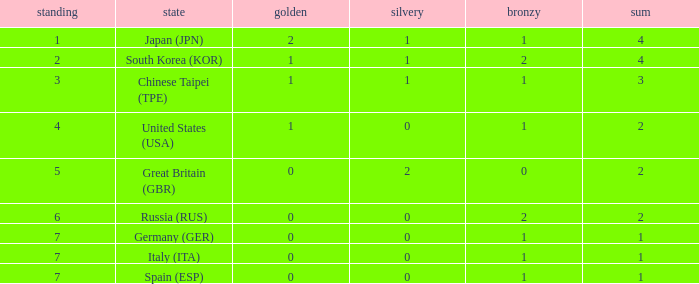What is the smallest number of gold of a country of rank 6, with 2 bronzes? None. 